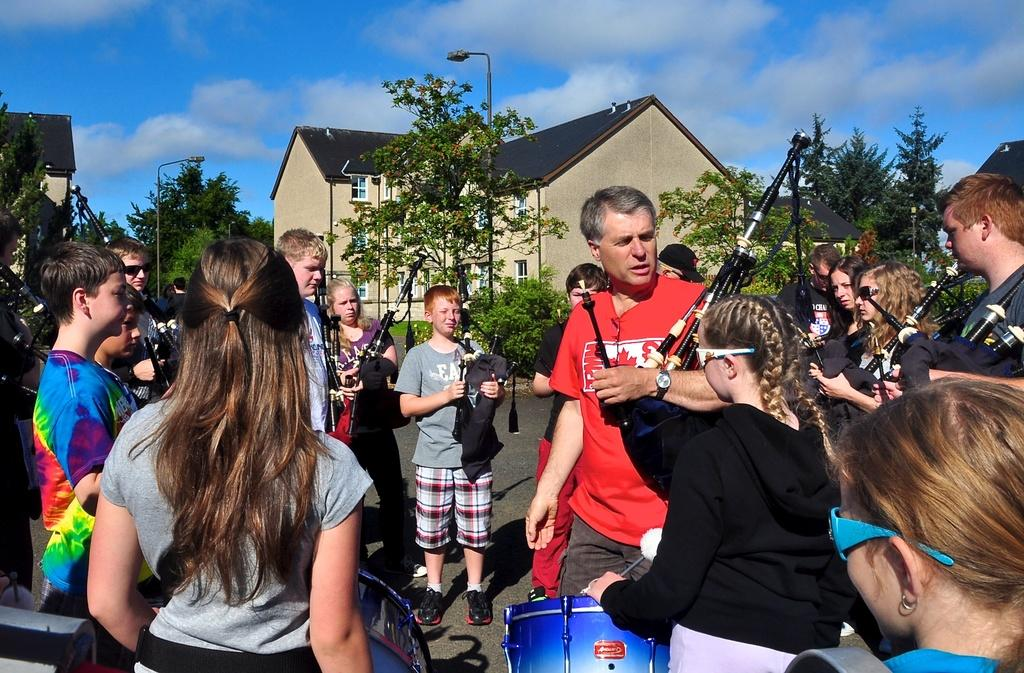What are the people in the image doing? There is a group of people standing on the road, and one person is playing the drums. Can you describe the surroundings in the image? There is a house and trees in the image, and the sky is visible. What type of coach can be seen in the image? There is no coach present in the image. How does the person playing the drums express their hate towards the trees in the image? The person playing the drums does not express any hate towards the trees in the image, as there is no indication of such emotions in the image. 